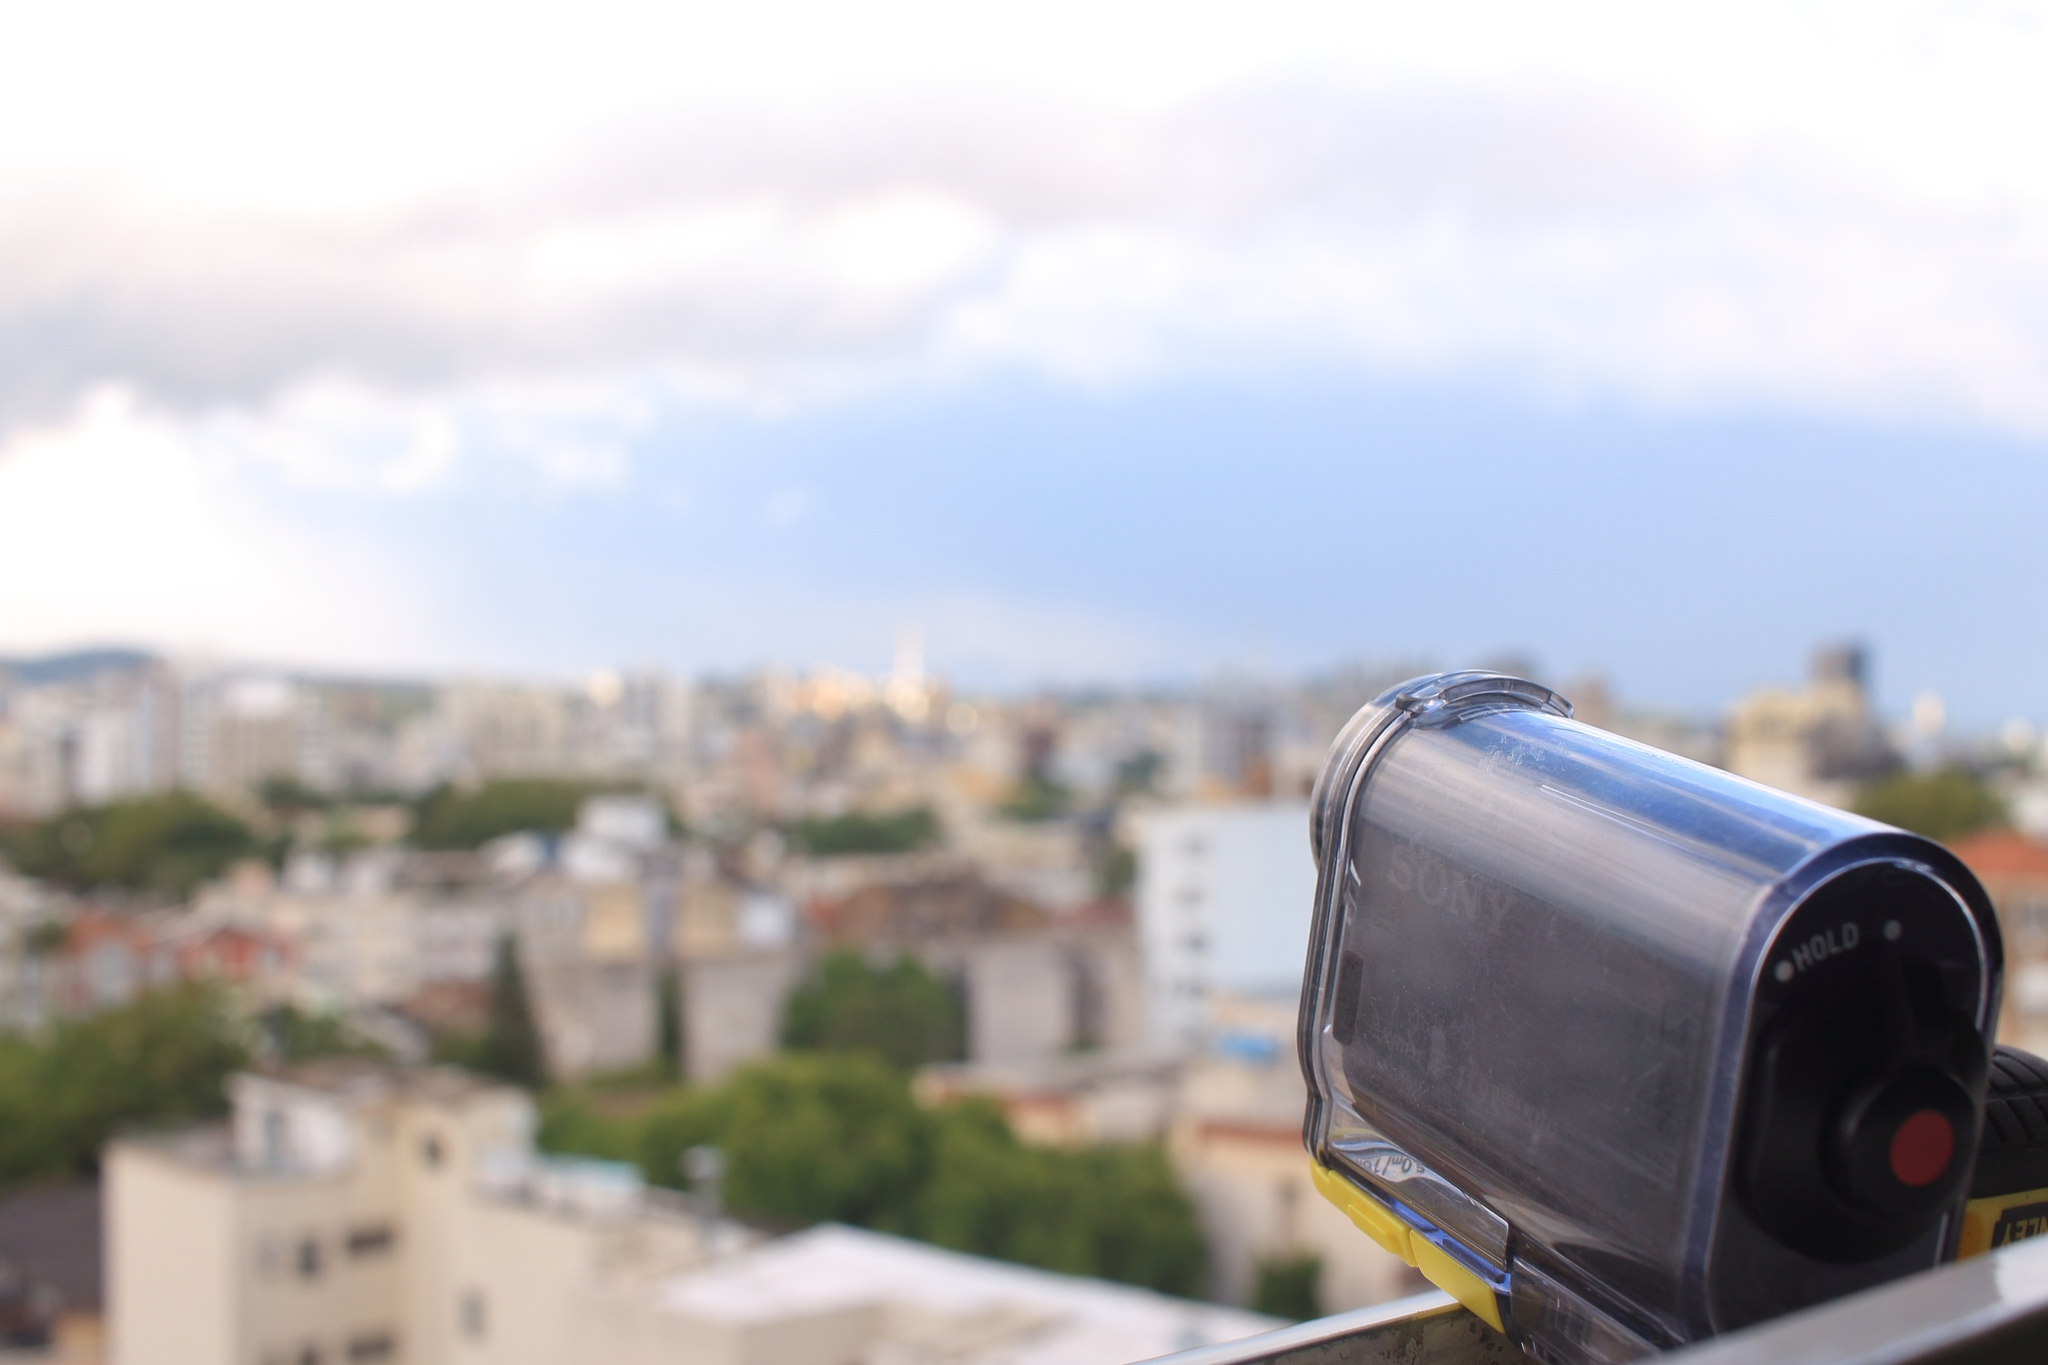What if the cityscape in the image were a bustling sci-fi metropolis? Describe the scene. If the cityscape in the image were a bustling sci-fi metropolis, the scene would be dramatically transformed. Skyscrapers would stretch upwards, adorned with neon lights and holographic advertisements. Flying vehicles would zip through the air, navigating between towering buildings with ease. The ground level would be a maze of high-tech infrastructure, with robots and cyborgs mingling with humans. Elevated walkways would connect futuristic buildings, and the sky might be filled with drones and airships, all contributing to the dynamic and vibrant atmosphere of a technologically advanced city. Imagine a scenario where this city is experiencing a festival. What might that look like? During a festival, this city would come alive with an explosion of colors and activities. Streets would be adorned with streamers and festive lights, and stalls selling delicious street food and unique crafts would line the pathways. Parades featuring vibrant floats, traditional dancers, and musicians would captivate spectators. Fireworks might light up the sky as night falls, adding to the celebratory atmosphere. Crowds of people, dressed in their finest attire, would fill the city, enjoying the cheerful decorations, live performances, and communal gatherings that commemorate the joyous occasion. 